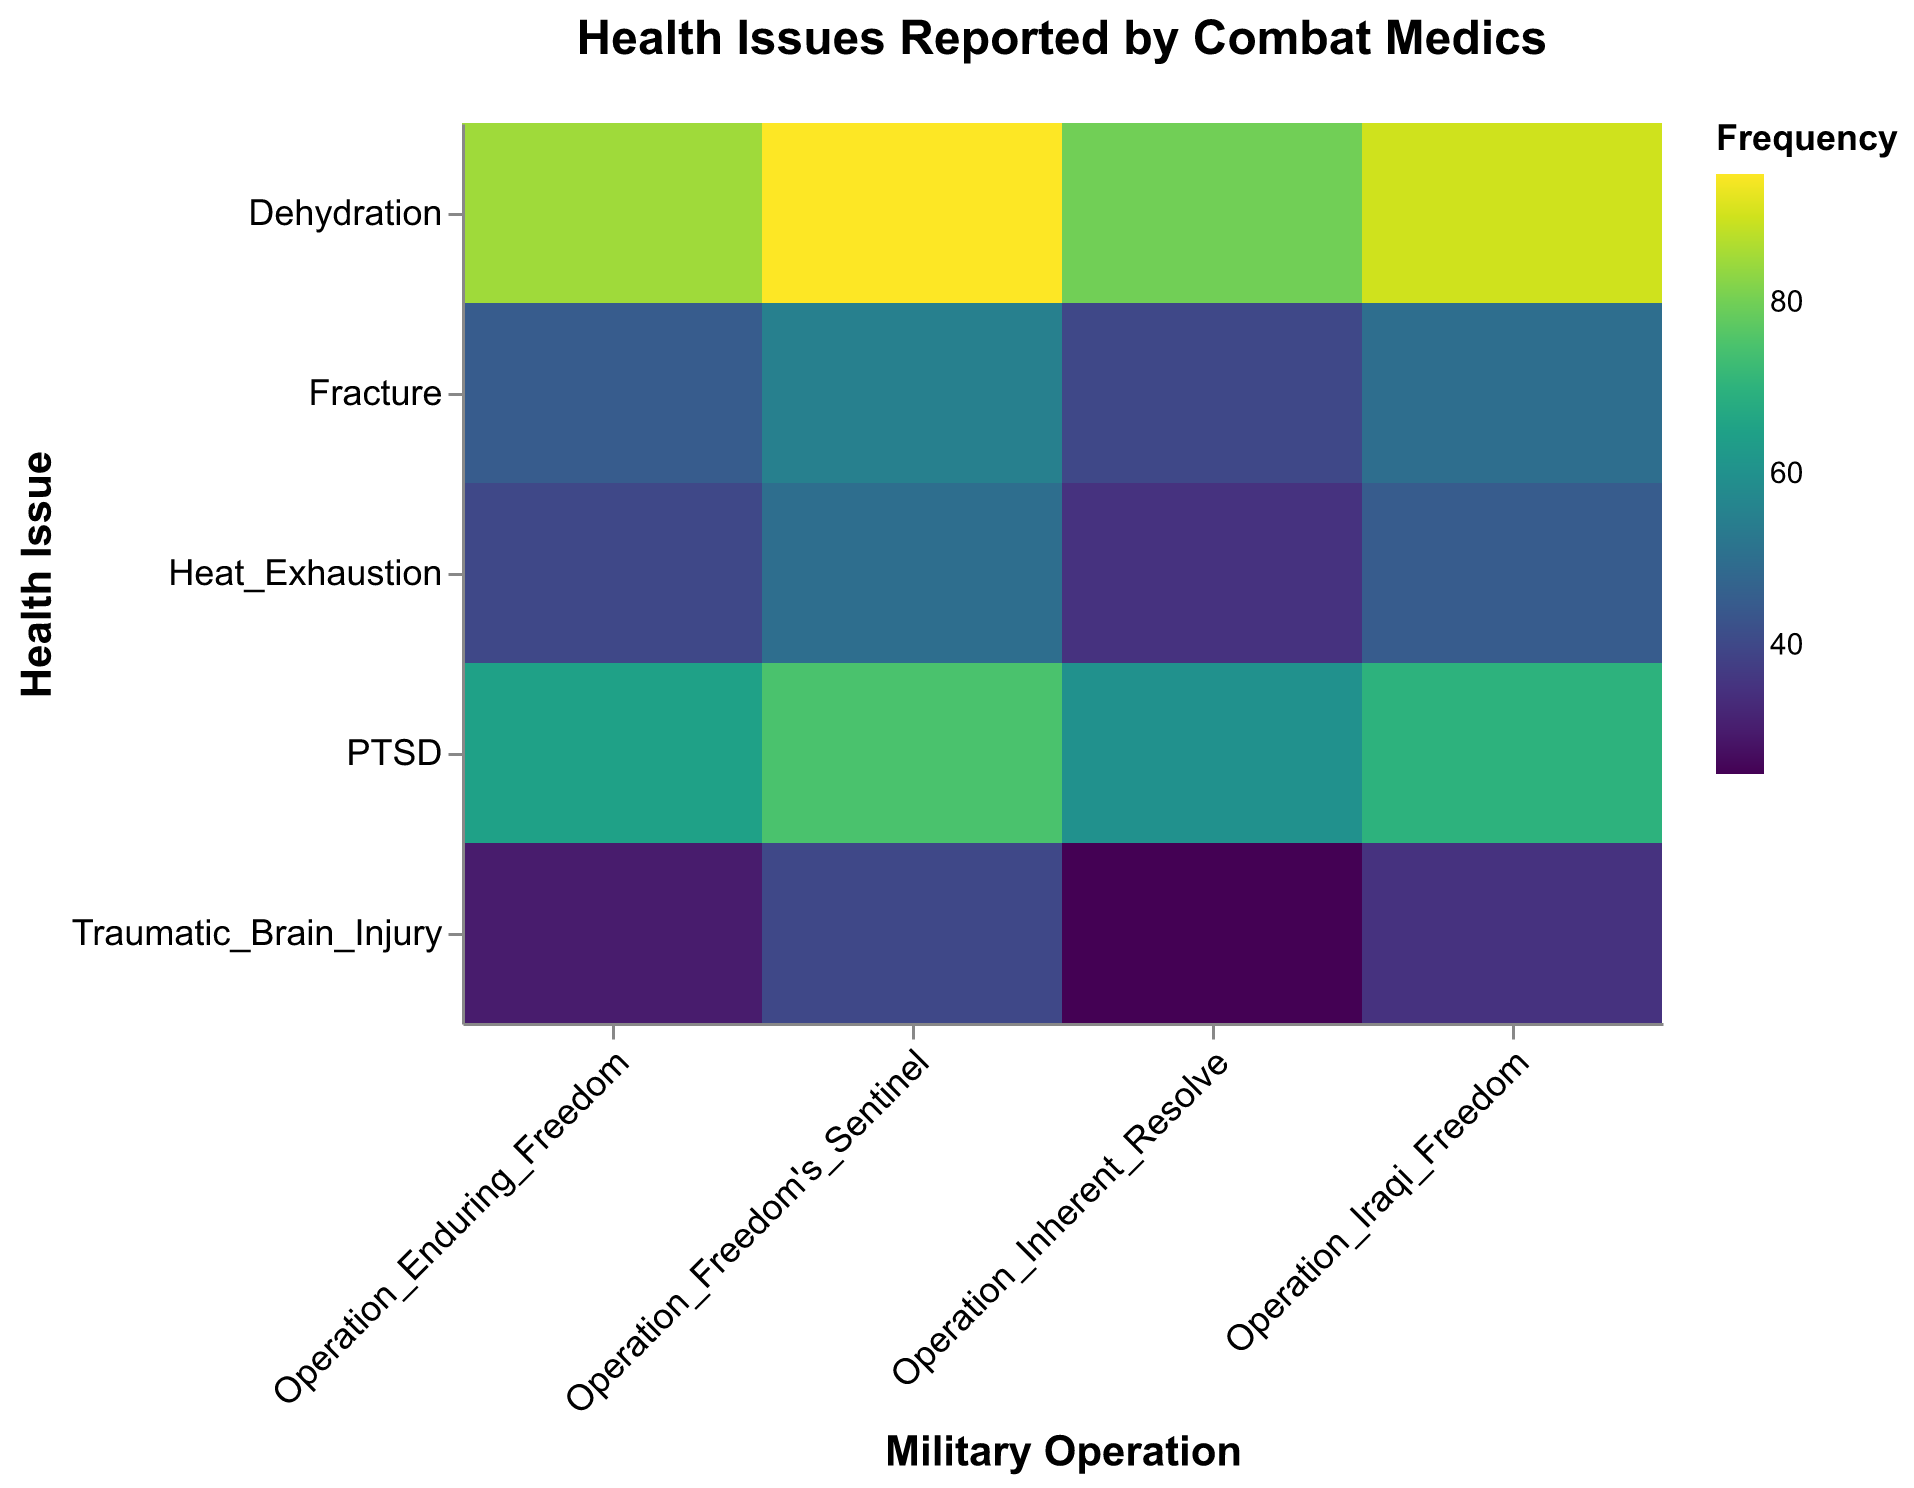What's the most frequently reported health issue during Operation Freedom's Sentinel? Look at the color intensity under Operation Freedom's Sentinel and identify the health issue with the darkest shade, indicating the highest frequency.
Answer: Dehydration Which military operation reported the lowest frequency of Traumatic Brain Injury? Compare the color intensity corresponding to Traumatic Brain Injury across all operations. The lightest shade has the lowest frequency.
Answer: Operation Inherent Resolve What is the total frequency of PTSD reported across all military operations? Sum the frequencies of PTSD reported in each operation: 65 (OEF) + 70 (OIF) + 60 (OIR) + 75 (OFS)
Answer: 270 Which health issue had the highest frequency during Operation Iraqi Freedom? Identify the darkest shade under Operation Iraqi Freedom, indicating the highest frequency.
Answer: Dehydration How does the frequency of fractures in Operation Enduring Freedom compare to those in Operation Inherent Resolve? Compare the shades for fractures between the two operations. Calculate the difference: 45 (OEF) - 40 (OIR)
Answer: Fractures were reported 5 times more frequently in Operation Enduring Freedom What's the average frequency of Heat Exhaustion reported across all operations? Sum the frequencies of Heat Exhaustion across all operations and divide by the number of operations: (40 + 45 + 35 + 50) / 4
Answer: 42.5 Which operation had the highest overall frequency of health issues reported? Look for the operation with the darkest overall segments and sum their frequencies: OEF: 45+30+65+40+85 = 265; OFS: 55+40+75+50+95 = 315; OIR: 40+25+60+35+80 = 240; OF: 50+35+70+45+90 = 290. The highest is OFS.
Answer: Operation Freedom's Sentinel How many health issues in total had a high severity frequency above 40? Count the instances where the frequency and severity are "High" and above 40: Fracture (OEF), Fracture (OFS), TBI (OFS), Fracture (OIF)
Answer: 4 